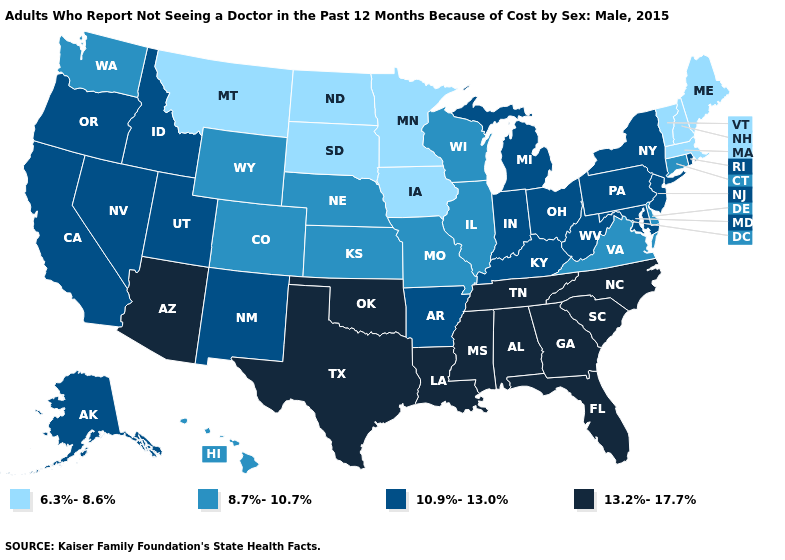Which states hav the highest value in the West?
Quick response, please. Arizona. Name the states that have a value in the range 8.7%-10.7%?
Give a very brief answer. Colorado, Connecticut, Delaware, Hawaii, Illinois, Kansas, Missouri, Nebraska, Virginia, Washington, Wisconsin, Wyoming. What is the highest value in states that border South Dakota?
Answer briefly. 8.7%-10.7%. Name the states that have a value in the range 6.3%-8.6%?
Answer briefly. Iowa, Maine, Massachusetts, Minnesota, Montana, New Hampshire, North Dakota, South Dakota, Vermont. What is the value of Kentucky?
Be succinct. 10.9%-13.0%. Does Virginia have the highest value in the South?
Write a very short answer. No. How many symbols are there in the legend?
Keep it brief. 4. Name the states that have a value in the range 8.7%-10.7%?
Be succinct. Colorado, Connecticut, Delaware, Hawaii, Illinois, Kansas, Missouri, Nebraska, Virginia, Washington, Wisconsin, Wyoming. Does South Carolina have the lowest value in the USA?
Give a very brief answer. No. Does the map have missing data?
Write a very short answer. No. Among the states that border Montana , does South Dakota have the lowest value?
Keep it brief. Yes. What is the lowest value in the MidWest?
Concise answer only. 6.3%-8.6%. Does Utah have the lowest value in the USA?
Give a very brief answer. No. Name the states that have a value in the range 10.9%-13.0%?
Keep it brief. Alaska, Arkansas, California, Idaho, Indiana, Kentucky, Maryland, Michigan, Nevada, New Jersey, New Mexico, New York, Ohio, Oregon, Pennsylvania, Rhode Island, Utah, West Virginia. 